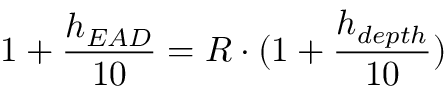Convert formula to latex. <formula><loc_0><loc_0><loc_500><loc_500>1 + { \frac { h _ { E A D } } { 1 0 } } = R \cdot ( 1 + { \frac { h _ { d e p t h } } { 1 0 } } )</formula> 